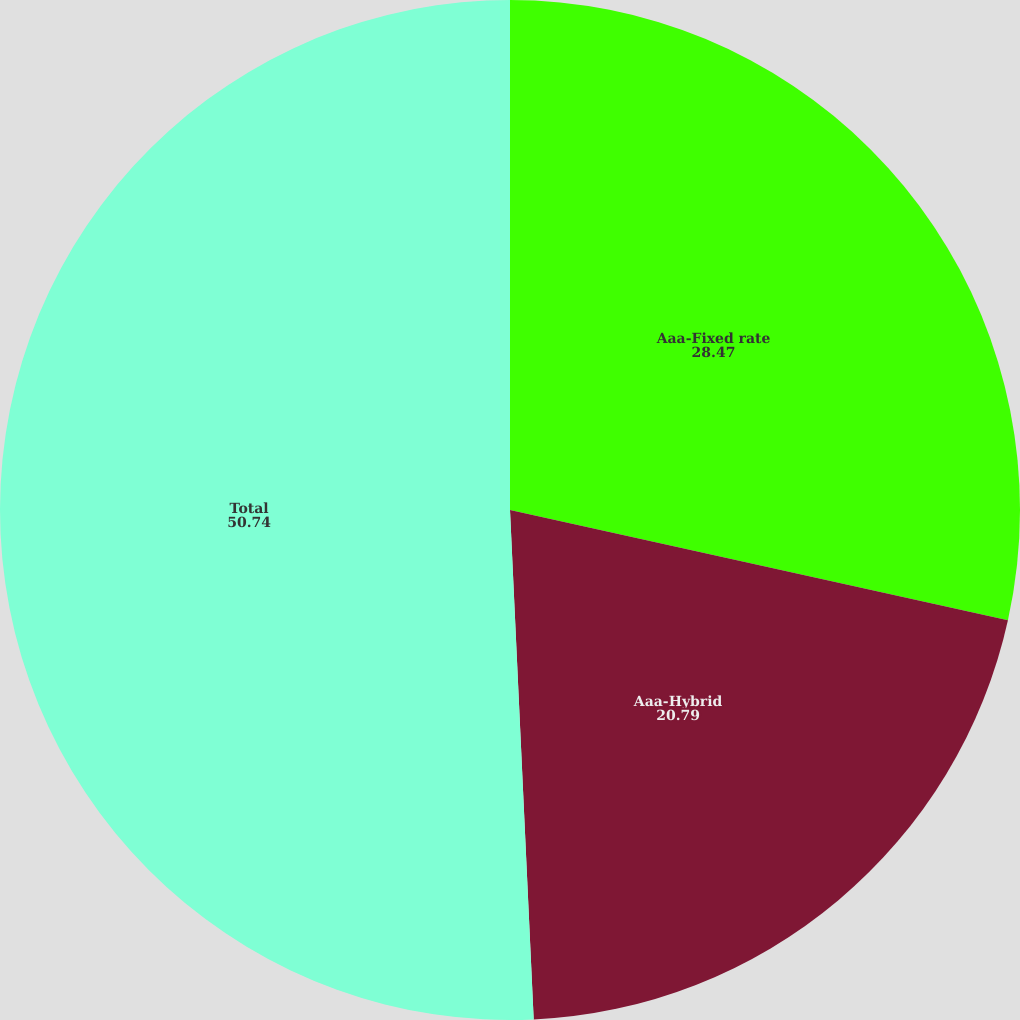Convert chart to OTSL. <chart><loc_0><loc_0><loc_500><loc_500><pie_chart><fcel>Aaa-Fixed rate<fcel>Aaa-Hybrid<fcel>Total<nl><fcel>28.47%<fcel>20.79%<fcel>50.74%<nl></chart> 